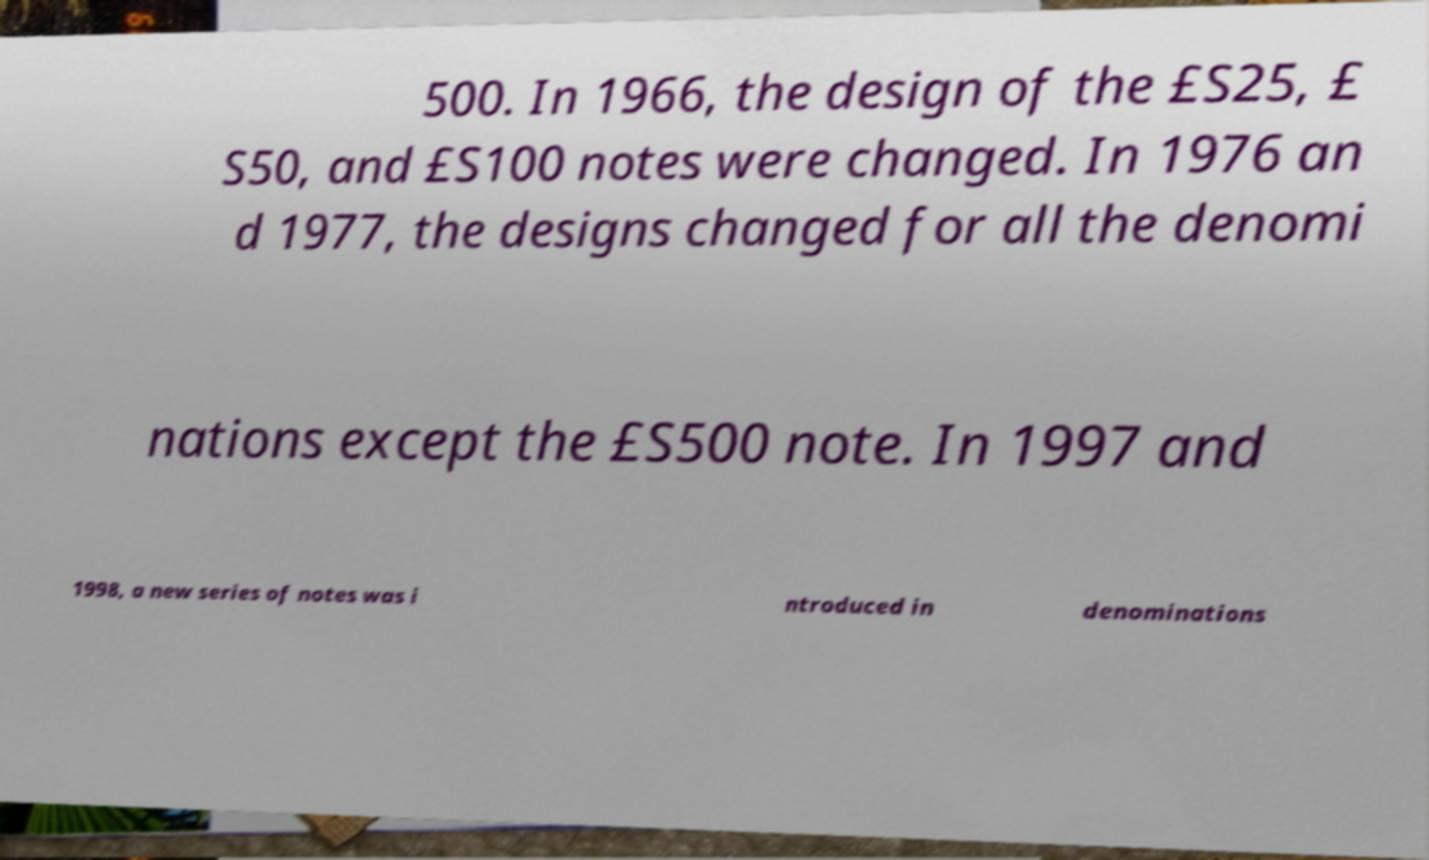Please identify and transcribe the text found in this image. 500. In 1966, the design of the £S25, £ S50, and £S100 notes were changed. In 1976 an d 1977, the designs changed for all the denomi nations except the £S500 note. In 1997 and 1998, a new series of notes was i ntroduced in denominations 